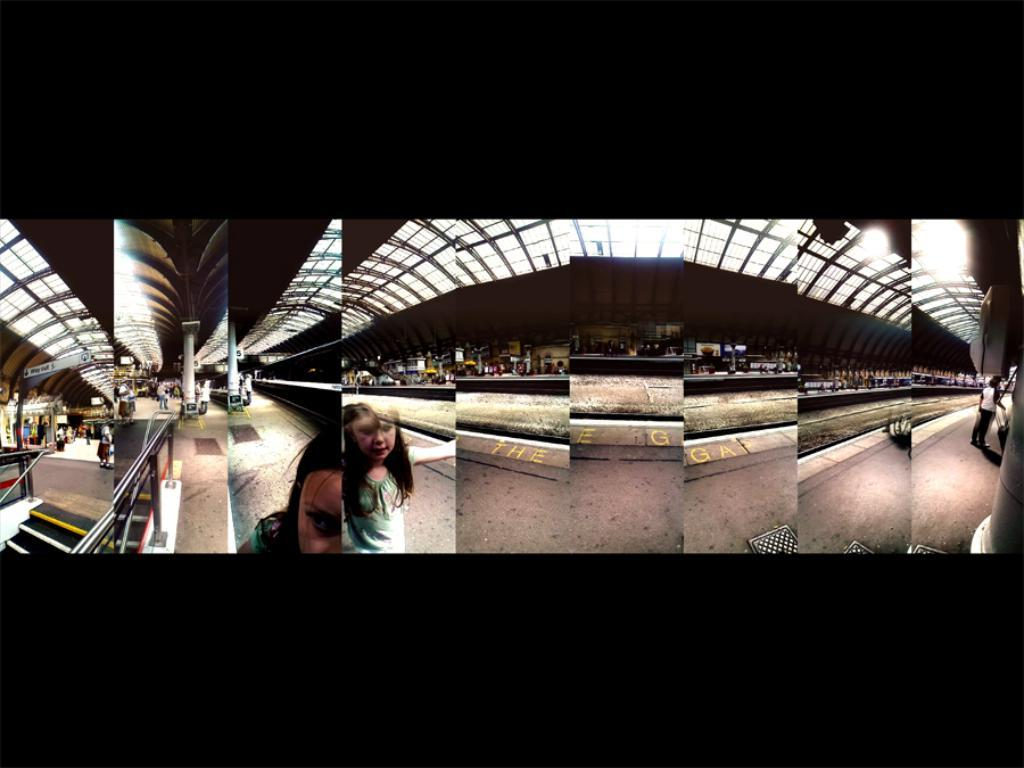What type of image is being described? The image is a collage. What can be seen on the collage? There is a platform in the image, and people are walking on it. Are there any architectural features in the image? Yes, there are steps on the bottom left side of the image. What type of parcel is being delivered on the platform in the image? There is no parcel being delivered in the image; it is a collage featuring a platform with people walking on it. What color is the quartz on the platform in the image? There is no quartz present in the image; the platform is likely made of a different material. 